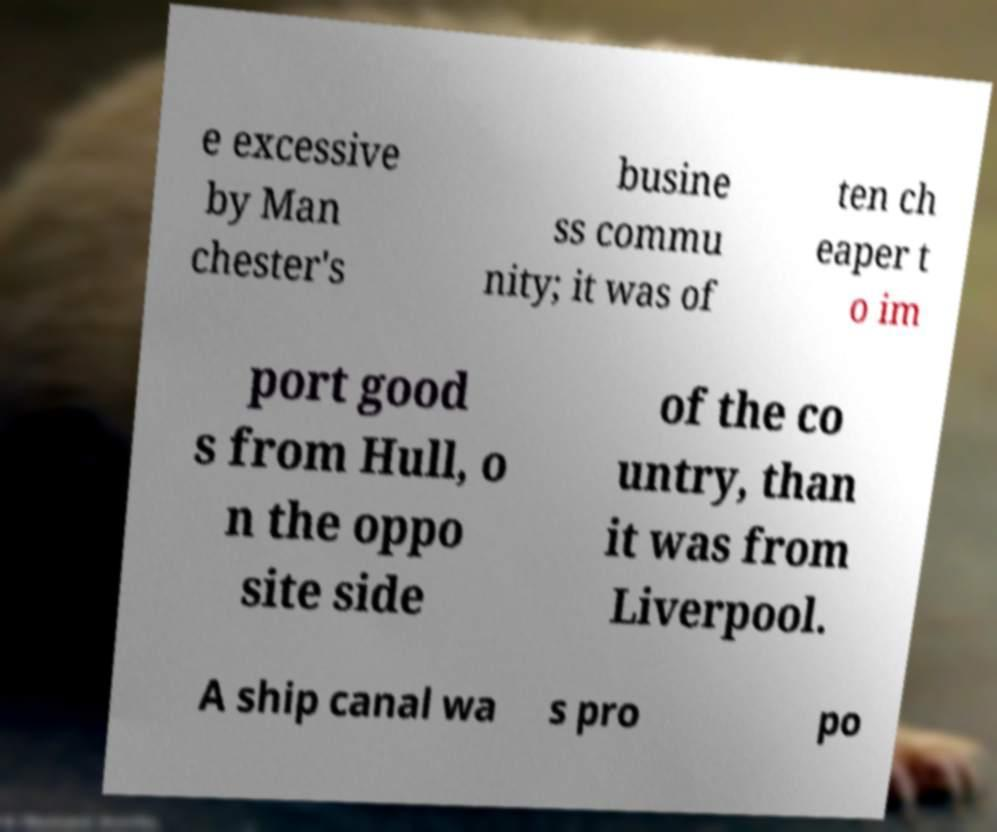Please read and relay the text visible in this image. What does it say? e excessive by Man chester's busine ss commu nity; it was of ten ch eaper t o im port good s from Hull, o n the oppo site side of the co untry, than it was from Liverpool. A ship canal wa s pro po 